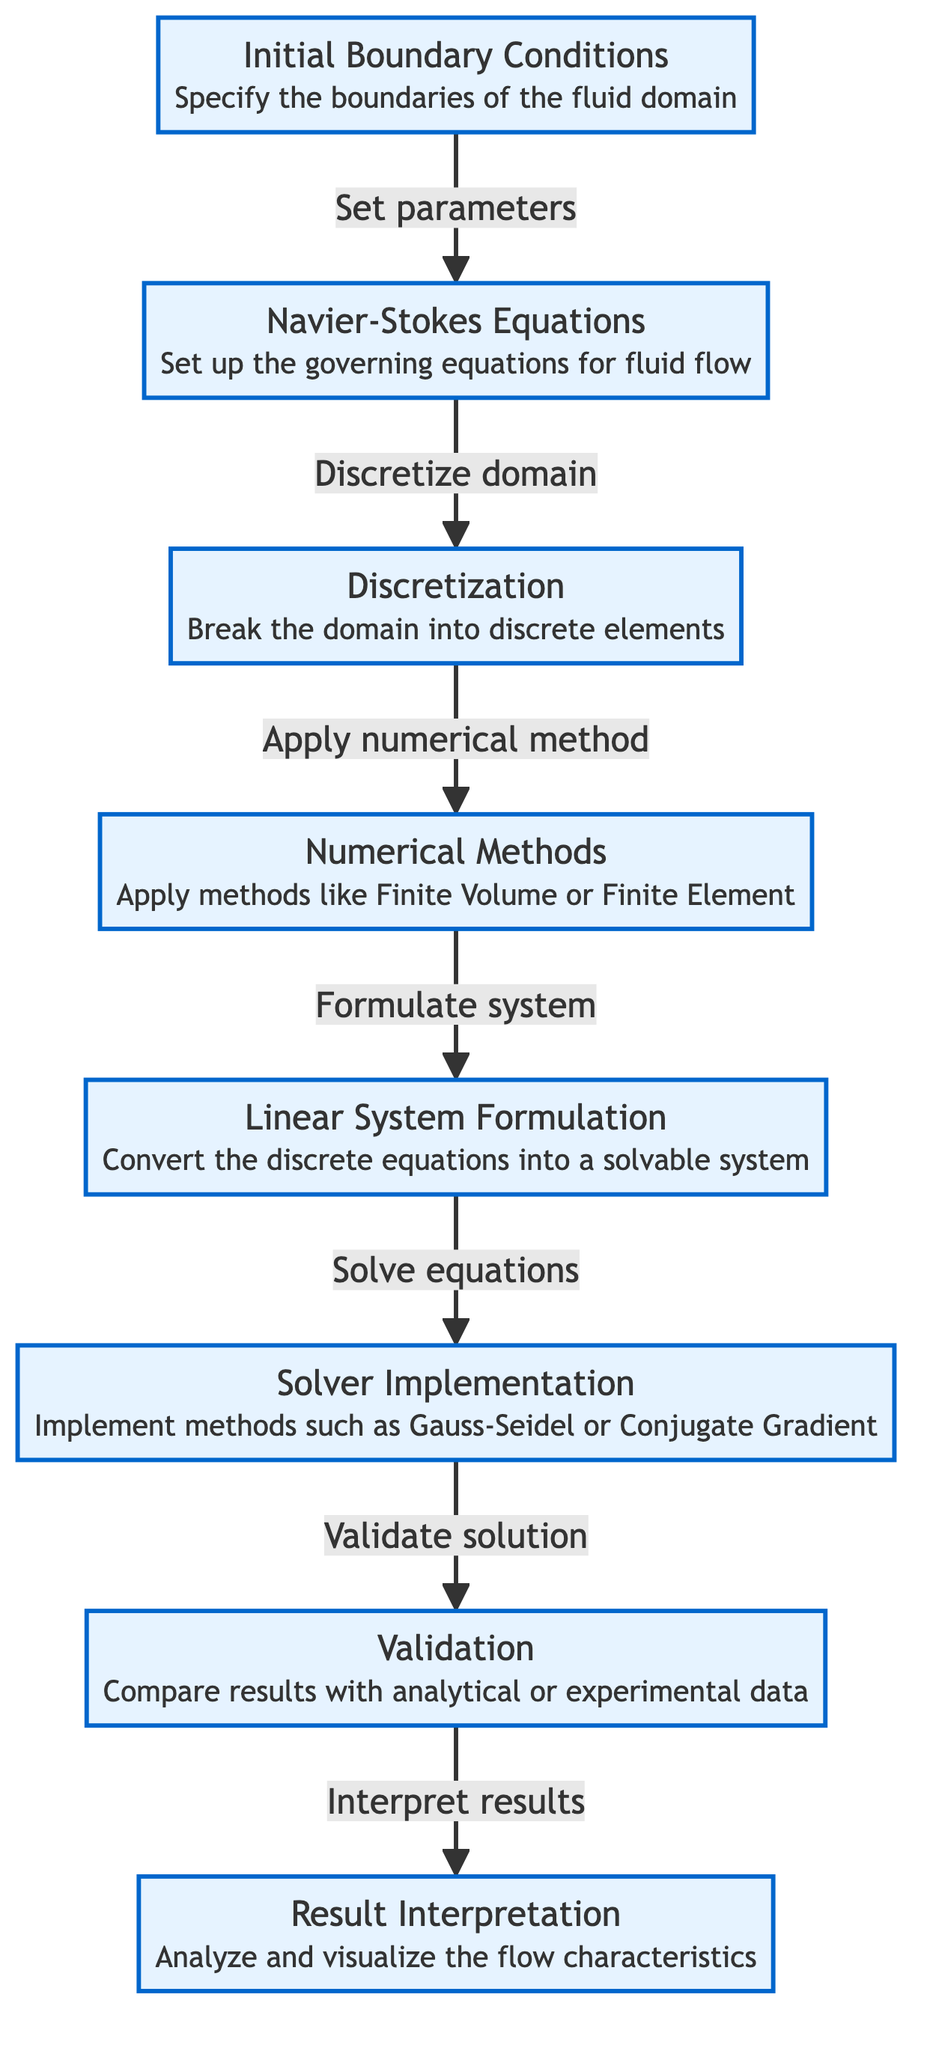What is the first step in the diagram? The first step in the diagram is "Initial Boundary Conditions," which defines the starting point for the fluid model.
Answer: Initial Boundary Conditions How many total steps are illustrated in the diagram? The diagram illustrates a total of eight steps, as indicated by the numbered boxes.
Answer: 8 Which step involves validating the solution? The validation of the solution occurs in the seventh step, which is explicitly labeled "Validation."
Answer: Validation What method is applied in the fourth step? The fourth step specifies that "Numerical Methods" are applied, referring to techniques like Finite Volume or Finite Element.
Answer: Numerical Methods What relationship exists between the second and third steps? The relationship is that the second step "Navier-Stokes Equations" leads into the third step "Discretization," indicating a sequence where the governing equations are used to prepare for discretization of the domain.
Answer: Discretize domain Which step requires comparison of results? The step requiring comparison of results is "Validation," where results are verified against either analytical or experimental data.
Answer: Validation In which step do we convert discrete equations? The conversion of discrete equations happens in the fifth step, labeled "Linear System Formulation," where the discrete equations are structured into a solvable system.
Answer: Linear System Formulation Which solving methods are mentioned in the sixth step? The sixth step mentions solving methods like "Gauss-Seidel or Conjugate Gradient," which are methods for finding solutions to the linear system.
Answer: Gauss-Seidel or Conjugate Gradient What follows after the solution is validated? After the solution is validated, the next process is "Result Interpretation," which focuses on analyzing and visualizing the characteristics of the fluid flow.
Answer: Result Interpretation 